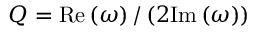Convert formula to latex. <formula><loc_0><loc_0><loc_500><loc_500>Q = R e \left ( \omega \right ) / \left ( 2 I m \left ( \omega \right ) \right )</formula> 